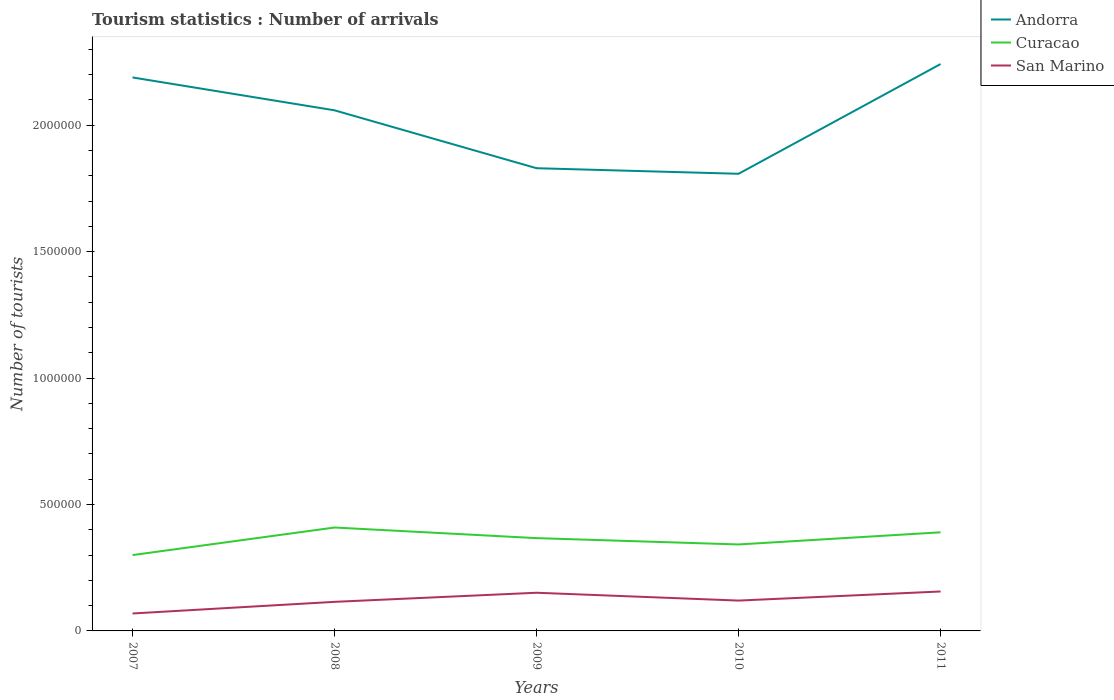Is the number of lines equal to the number of legend labels?
Your answer should be compact. Yes. Across all years, what is the maximum number of tourist arrivals in Curacao?
Make the answer very short. 3.00e+05. In which year was the number of tourist arrivals in Curacao maximum?
Provide a succinct answer. 2007. What is the total number of tourist arrivals in Curacao in the graph?
Your answer should be compact. -6.70e+04. What is the difference between the highest and the second highest number of tourist arrivals in Curacao?
Your answer should be very brief. 1.09e+05. What is the difference between the highest and the lowest number of tourist arrivals in Curacao?
Give a very brief answer. 3. Are the values on the major ticks of Y-axis written in scientific E-notation?
Give a very brief answer. No. Does the graph contain any zero values?
Provide a short and direct response. No. Where does the legend appear in the graph?
Your answer should be very brief. Top right. How many legend labels are there?
Ensure brevity in your answer.  3. How are the legend labels stacked?
Offer a very short reply. Vertical. What is the title of the graph?
Your response must be concise. Tourism statistics : Number of arrivals. Does "Madagascar" appear as one of the legend labels in the graph?
Ensure brevity in your answer.  No. What is the label or title of the X-axis?
Offer a terse response. Years. What is the label or title of the Y-axis?
Keep it short and to the point. Number of tourists. What is the Number of tourists in Andorra in 2007?
Offer a terse response. 2.19e+06. What is the Number of tourists of San Marino in 2007?
Your answer should be compact. 6.90e+04. What is the Number of tourists in Andorra in 2008?
Provide a short and direct response. 2.06e+06. What is the Number of tourists in Curacao in 2008?
Give a very brief answer. 4.09e+05. What is the Number of tourists of San Marino in 2008?
Your answer should be very brief. 1.15e+05. What is the Number of tourists of Andorra in 2009?
Offer a very short reply. 1.83e+06. What is the Number of tourists in Curacao in 2009?
Provide a succinct answer. 3.67e+05. What is the Number of tourists in San Marino in 2009?
Keep it short and to the point. 1.51e+05. What is the Number of tourists in Andorra in 2010?
Your answer should be very brief. 1.81e+06. What is the Number of tourists in Curacao in 2010?
Your answer should be compact. 3.42e+05. What is the Number of tourists in San Marino in 2010?
Your answer should be very brief. 1.20e+05. What is the Number of tourists of Andorra in 2011?
Ensure brevity in your answer.  2.24e+06. What is the Number of tourists of Curacao in 2011?
Give a very brief answer. 3.90e+05. What is the Number of tourists of San Marino in 2011?
Keep it short and to the point. 1.56e+05. Across all years, what is the maximum Number of tourists in Andorra?
Provide a short and direct response. 2.24e+06. Across all years, what is the maximum Number of tourists of Curacao?
Your answer should be compact. 4.09e+05. Across all years, what is the maximum Number of tourists of San Marino?
Provide a short and direct response. 1.56e+05. Across all years, what is the minimum Number of tourists in Andorra?
Keep it short and to the point. 1.81e+06. Across all years, what is the minimum Number of tourists in Curacao?
Offer a terse response. 3.00e+05. Across all years, what is the minimum Number of tourists of San Marino?
Make the answer very short. 6.90e+04. What is the total Number of tourists in Andorra in the graph?
Provide a short and direct response. 1.01e+07. What is the total Number of tourists of Curacao in the graph?
Your response must be concise. 1.81e+06. What is the total Number of tourists of San Marino in the graph?
Make the answer very short. 6.11e+05. What is the difference between the Number of tourists of Curacao in 2007 and that in 2008?
Provide a short and direct response. -1.09e+05. What is the difference between the Number of tourists in San Marino in 2007 and that in 2008?
Give a very brief answer. -4.60e+04. What is the difference between the Number of tourists of Andorra in 2007 and that in 2009?
Give a very brief answer. 3.59e+05. What is the difference between the Number of tourists in Curacao in 2007 and that in 2009?
Give a very brief answer. -6.70e+04. What is the difference between the Number of tourists in San Marino in 2007 and that in 2009?
Offer a terse response. -8.20e+04. What is the difference between the Number of tourists of Andorra in 2007 and that in 2010?
Provide a short and direct response. 3.81e+05. What is the difference between the Number of tourists in Curacao in 2007 and that in 2010?
Your answer should be very brief. -4.20e+04. What is the difference between the Number of tourists in San Marino in 2007 and that in 2010?
Your answer should be very brief. -5.10e+04. What is the difference between the Number of tourists of Andorra in 2007 and that in 2011?
Your answer should be compact. -5.30e+04. What is the difference between the Number of tourists of San Marino in 2007 and that in 2011?
Give a very brief answer. -8.70e+04. What is the difference between the Number of tourists of Andorra in 2008 and that in 2009?
Ensure brevity in your answer.  2.29e+05. What is the difference between the Number of tourists in Curacao in 2008 and that in 2009?
Give a very brief answer. 4.20e+04. What is the difference between the Number of tourists of San Marino in 2008 and that in 2009?
Make the answer very short. -3.60e+04. What is the difference between the Number of tourists of Andorra in 2008 and that in 2010?
Offer a terse response. 2.51e+05. What is the difference between the Number of tourists in Curacao in 2008 and that in 2010?
Your answer should be compact. 6.70e+04. What is the difference between the Number of tourists in San Marino in 2008 and that in 2010?
Make the answer very short. -5000. What is the difference between the Number of tourists in Andorra in 2008 and that in 2011?
Your response must be concise. -1.83e+05. What is the difference between the Number of tourists of Curacao in 2008 and that in 2011?
Make the answer very short. 1.90e+04. What is the difference between the Number of tourists of San Marino in 2008 and that in 2011?
Your response must be concise. -4.10e+04. What is the difference between the Number of tourists of Andorra in 2009 and that in 2010?
Your answer should be very brief. 2.20e+04. What is the difference between the Number of tourists in Curacao in 2009 and that in 2010?
Your answer should be compact. 2.50e+04. What is the difference between the Number of tourists of San Marino in 2009 and that in 2010?
Offer a very short reply. 3.10e+04. What is the difference between the Number of tourists in Andorra in 2009 and that in 2011?
Offer a terse response. -4.12e+05. What is the difference between the Number of tourists in Curacao in 2009 and that in 2011?
Offer a very short reply. -2.30e+04. What is the difference between the Number of tourists of San Marino in 2009 and that in 2011?
Your response must be concise. -5000. What is the difference between the Number of tourists in Andorra in 2010 and that in 2011?
Keep it short and to the point. -4.34e+05. What is the difference between the Number of tourists of Curacao in 2010 and that in 2011?
Keep it short and to the point. -4.80e+04. What is the difference between the Number of tourists in San Marino in 2010 and that in 2011?
Make the answer very short. -3.60e+04. What is the difference between the Number of tourists of Andorra in 2007 and the Number of tourists of Curacao in 2008?
Keep it short and to the point. 1.78e+06. What is the difference between the Number of tourists of Andorra in 2007 and the Number of tourists of San Marino in 2008?
Make the answer very short. 2.07e+06. What is the difference between the Number of tourists in Curacao in 2007 and the Number of tourists in San Marino in 2008?
Keep it short and to the point. 1.85e+05. What is the difference between the Number of tourists in Andorra in 2007 and the Number of tourists in Curacao in 2009?
Offer a terse response. 1.82e+06. What is the difference between the Number of tourists of Andorra in 2007 and the Number of tourists of San Marino in 2009?
Offer a terse response. 2.04e+06. What is the difference between the Number of tourists in Curacao in 2007 and the Number of tourists in San Marino in 2009?
Keep it short and to the point. 1.49e+05. What is the difference between the Number of tourists in Andorra in 2007 and the Number of tourists in Curacao in 2010?
Your answer should be compact. 1.85e+06. What is the difference between the Number of tourists in Andorra in 2007 and the Number of tourists in San Marino in 2010?
Ensure brevity in your answer.  2.07e+06. What is the difference between the Number of tourists of Andorra in 2007 and the Number of tourists of Curacao in 2011?
Keep it short and to the point. 1.80e+06. What is the difference between the Number of tourists in Andorra in 2007 and the Number of tourists in San Marino in 2011?
Your response must be concise. 2.03e+06. What is the difference between the Number of tourists in Curacao in 2007 and the Number of tourists in San Marino in 2011?
Your answer should be very brief. 1.44e+05. What is the difference between the Number of tourists in Andorra in 2008 and the Number of tourists in Curacao in 2009?
Provide a succinct answer. 1.69e+06. What is the difference between the Number of tourists of Andorra in 2008 and the Number of tourists of San Marino in 2009?
Your response must be concise. 1.91e+06. What is the difference between the Number of tourists in Curacao in 2008 and the Number of tourists in San Marino in 2009?
Offer a very short reply. 2.58e+05. What is the difference between the Number of tourists of Andorra in 2008 and the Number of tourists of Curacao in 2010?
Offer a very short reply. 1.72e+06. What is the difference between the Number of tourists in Andorra in 2008 and the Number of tourists in San Marino in 2010?
Your answer should be compact. 1.94e+06. What is the difference between the Number of tourists of Curacao in 2008 and the Number of tourists of San Marino in 2010?
Your answer should be compact. 2.89e+05. What is the difference between the Number of tourists of Andorra in 2008 and the Number of tourists of Curacao in 2011?
Provide a short and direct response. 1.67e+06. What is the difference between the Number of tourists of Andorra in 2008 and the Number of tourists of San Marino in 2011?
Your answer should be compact. 1.90e+06. What is the difference between the Number of tourists of Curacao in 2008 and the Number of tourists of San Marino in 2011?
Keep it short and to the point. 2.53e+05. What is the difference between the Number of tourists in Andorra in 2009 and the Number of tourists in Curacao in 2010?
Give a very brief answer. 1.49e+06. What is the difference between the Number of tourists of Andorra in 2009 and the Number of tourists of San Marino in 2010?
Ensure brevity in your answer.  1.71e+06. What is the difference between the Number of tourists in Curacao in 2009 and the Number of tourists in San Marino in 2010?
Make the answer very short. 2.47e+05. What is the difference between the Number of tourists in Andorra in 2009 and the Number of tourists in Curacao in 2011?
Offer a very short reply. 1.44e+06. What is the difference between the Number of tourists of Andorra in 2009 and the Number of tourists of San Marino in 2011?
Give a very brief answer. 1.67e+06. What is the difference between the Number of tourists of Curacao in 2009 and the Number of tourists of San Marino in 2011?
Offer a very short reply. 2.11e+05. What is the difference between the Number of tourists of Andorra in 2010 and the Number of tourists of Curacao in 2011?
Ensure brevity in your answer.  1.42e+06. What is the difference between the Number of tourists of Andorra in 2010 and the Number of tourists of San Marino in 2011?
Provide a succinct answer. 1.65e+06. What is the difference between the Number of tourists in Curacao in 2010 and the Number of tourists in San Marino in 2011?
Provide a succinct answer. 1.86e+05. What is the average Number of tourists of Andorra per year?
Provide a succinct answer. 2.03e+06. What is the average Number of tourists of Curacao per year?
Your answer should be very brief. 3.62e+05. What is the average Number of tourists in San Marino per year?
Offer a terse response. 1.22e+05. In the year 2007, what is the difference between the Number of tourists in Andorra and Number of tourists in Curacao?
Give a very brief answer. 1.89e+06. In the year 2007, what is the difference between the Number of tourists of Andorra and Number of tourists of San Marino?
Offer a terse response. 2.12e+06. In the year 2007, what is the difference between the Number of tourists of Curacao and Number of tourists of San Marino?
Your answer should be very brief. 2.31e+05. In the year 2008, what is the difference between the Number of tourists of Andorra and Number of tourists of Curacao?
Offer a very short reply. 1.65e+06. In the year 2008, what is the difference between the Number of tourists in Andorra and Number of tourists in San Marino?
Give a very brief answer. 1.94e+06. In the year 2008, what is the difference between the Number of tourists in Curacao and Number of tourists in San Marino?
Give a very brief answer. 2.94e+05. In the year 2009, what is the difference between the Number of tourists of Andorra and Number of tourists of Curacao?
Provide a succinct answer. 1.46e+06. In the year 2009, what is the difference between the Number of tourists in Andorra and Number of tourists in San Marino?
Ensure brevity in your answer.  1.68e+06. In the year 2009, what is the difference between the Number of tourists in Curacao and Number of tourists in San Marino?
Make the answer very short. 2.16e+05. In the year 2010, what is the difference between the Number of tourists in Andorra and Number of tourists in Curacao?
Make the answer very short. 1.47e+06. In the year 2010, what is the difference between the Number of tourists of Andorra and Number of tourists of San Marino?
Offer a very short reply. 1.69e+06. In the year 2010, what is the difference between the Number of tourists in Curacao and Number of tourists in San Marino?
Offer a very short reply. 2.22e+05. In the year 2011, what is the difference between the Number of tourists of Andorra and Number of tourists of Curacao?
Give a very brief answer. 1.85e+06. In the year 2011, what is the difference between the Number of tourists of Andorra and Number of tourists of San Marino?
Provide a succinct answer. 2.09e+06. In the year 2011, what is the difference between the Number of tourists in Curacao and Number of tourists in San Marino?
Your response must be concise. 2.34e+05. What is the ratio of the Number of tourists in Andorra in 2007 to that in 2008?
Your response must be concise. 1.06. What is the ratio of the Number of tourists of Curacao in 2007 to that in 2008?
Your answer should be very brief. 0.73. What is the ratio of the Number of tourists of Andorra in 2007 to that in 2009?
Your response must be concise. 1.2. What is the ratio of the Number of tourists of Curacao in 2007 to that in 2009?
Your response must be concise. 0.82. What is the ratio of the Number of tourists of San Marino in 2007 to that in 2009?
Offer a very short reply. 0.46. What is the ratio of the Number of tourists of Andorra in 2007 to that in 2010?
Ensure brevity in your answer.  1.21. What is the ratio of the Number of tourists in Curacao in 2007 to that in 2010?
Your answer should be very brief. 0.88. What is the ratio of the Number of tourists in San Marino in 2007 to that in 2010?
Offer a terse response. 0.57. What is the ratio of the Number of tourists of Andorra in 2007 to that in 2011?
Keep it short and to the point. 0.98. What is the ratio of the Number of tourists of Curacao in 2007 to that in 2011?
Your response must be concise. 0.77. What is the ratio of the Number of tourists in San Marino in 2007 to that in 2011?
Give a very brief answer. 0.44. What is the ratio of the Number of tourists in Andorra in 2008 to that in 2009?
Offer a very short reply. 1.13. What is the ratio of the Number of tourists of Curacao in 2008 to that in 2009?
Make the answer very short. 1.11. What is the ratio of the Number of tourists of San Marino in 2008 to that in 2009?
Your answer should be compact. 0.76. What is the ratio of the Number of tourists of Andorra in 2008 to that in 2010?
Provide a short and direct response. 1.14. What is the ratio of the Number of tourists in Curacao in 2008 to that in 2010?
Your response must be concise. 1.2. What is the ratio of the Number of tourists in San Marino in 2008 to that in 2010?
Provide a short and direct response. 0.96. What is the ratio of the Number of tourists of Andorra in 2008 to that in 2011?
Offer a terse response. 0.92. What is the ratio of the Number of tourists in Curacao in 2008 to that in 2011?
Keep it short and to the point. 1.05. What is the ratio of the Number of tourists in San Marino in 2008 to that in 2011?
Offer a terse response. 0.74. What is the ratio of the Number of tourists in Andorra in 2009 to that in 2010?
Provide a succinct answer. 1.01. What is the ratio of the Number of tourists of Curacao in 2009 to that in 2010?
Your answer should be very brief. 1.07. What is the ratio of the Number of tourists in San Marino in 2009 to that in 2010?
Offer a very short reply. 1.26. What is the ratio of the Number of tourists of Andorra in 2009 to that in 2011?
Your answer should be compact. 0.82. What is the ratio of the Number of tourists of Curacao in 2009 to that in 2011?
Your answer should be very brief. 0.94. What is the ratio of the Number of tourists of San Marino in 2009 to that in 2011?
Provide a short and direct response. 0.97. What is the ratio of the Number of tourists of Andorra in 2010 to that in 2011?
Provide a succinct answer. 0.81. What is the ratio of the Number of tourists in Curacao in 2010 to that in 2011?
Make the answer very short. 0.88. What is the ratio of the Number of tourists of San Marino in 2010 to that in 2011?
Ensure brevity in your answer.  0.77. What is the difference between the highest and the second highest Number of tourists of Andorra?
Keep it short and to the point. 5.30e+04. What is the difference between the highest and the second highest Number of tourists of Curacao?
Give a very brief answer. 1.90e+04. What is the difference between the highest and the lowest Number of tourists in Andorra?
Give a very brief answer. 4.34e+05. What is the difference between the highest and the lowest Number of tourists in Curacao?
Your answer should be very brief. 1.09e+05. What is the difference between the highest and the lowest Number of tourists in San Marino?
Your response must be concise. 8.70e+04. 